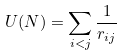<formula> <loc_0><loc_0><loc_500><loc_500>U ( N ) = \sum _ { i < j } \frac { 1 } { r _ { i j } }</formula> 